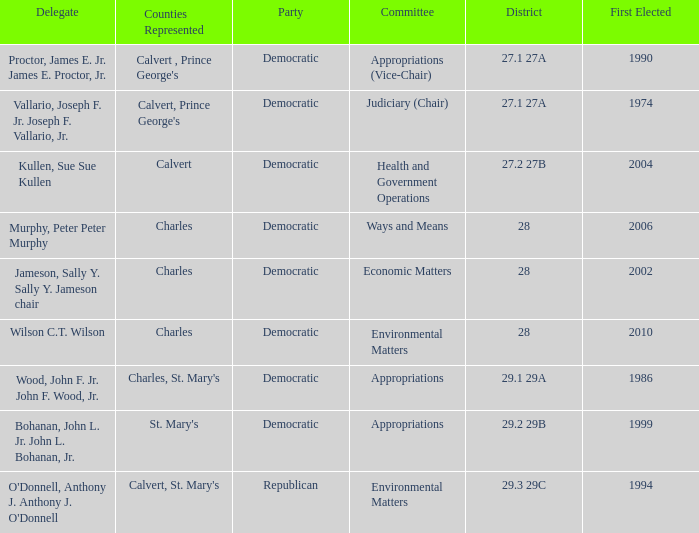When first elected was 2006, who was the delegate? Murphy, Peter Peter Murphy. 